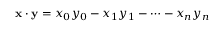<formula> <loc_0><loc_0><loc_500><loc_500>x \cdot y = x _ { 0 } y _ { 0 } - x _ { 1 } y _ { 1 } - \cdots - x _ { n } y _ { n }</formula> 